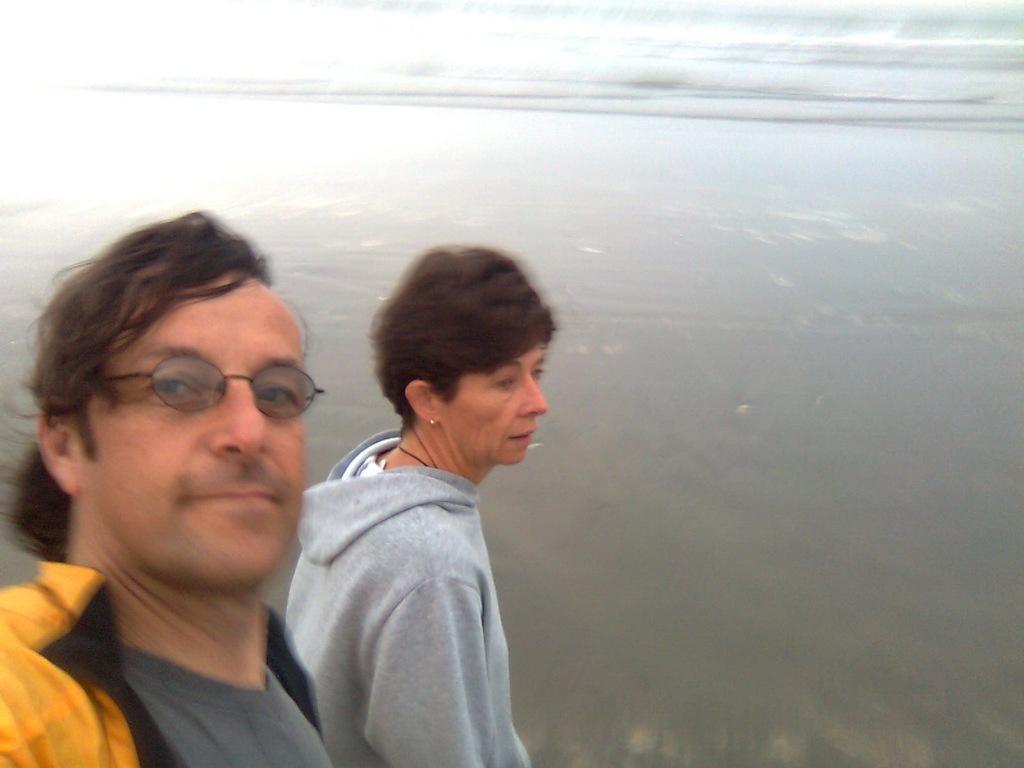Describe this image in one or two sentences. In this image we can see a man and a lady. In the background there is water. 